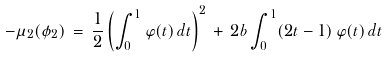<formula> <loc_0><loc_0><loc_500><loc_500>- \mu _ { 2 } ( \phi _ { 2 } ) \, = \, \frac { 1 } { 2 } \left ( \int _ { 0 } ^ { 1 } \varphi ( t ) \, d t \right ) ^ { 2 } \, + \, 2 b \int _ { 0 } ^ { 1 } ( 2 t - 1 ) \, \varphi ( t ) \, d t \,</formula> 